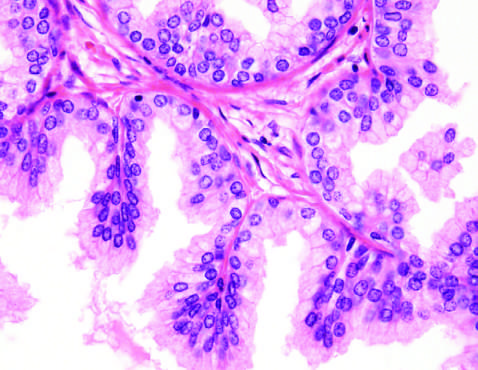s the nodularity caused predominantly by stromal, rather than glandular, proliferation in other cases of nodular hyperplasia?
Answer the question using a single word or phrase. Yes 